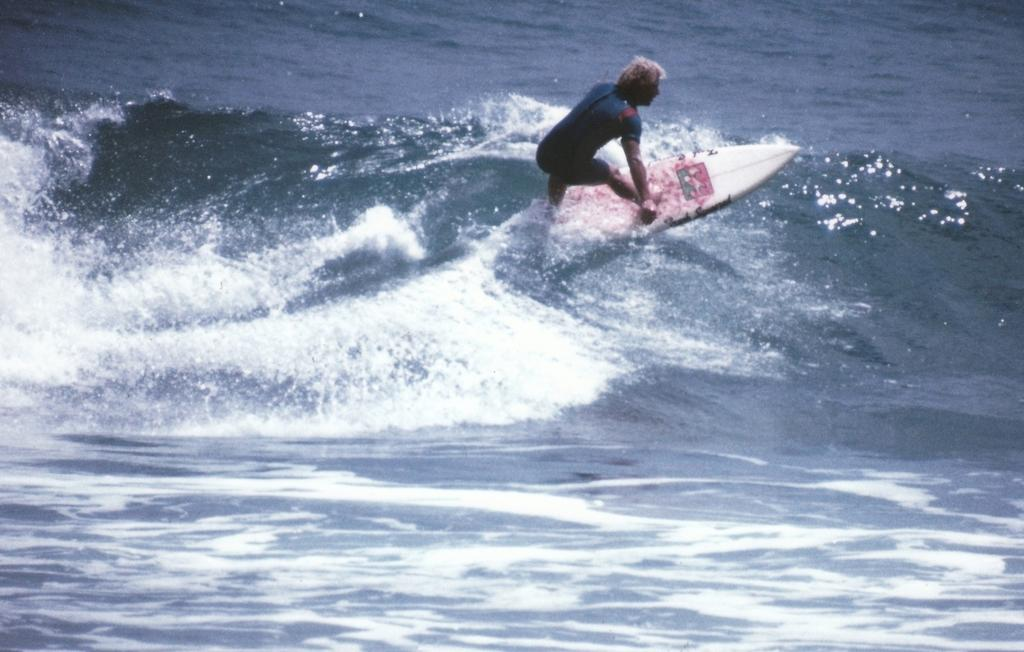What is the main subject of the image? There is a person in the image. What is the person doing in the image? The person is surfing on the water. How many men are riding horses in the image? There are no men or horses present in the image. Are there any deer visible in the image? There are no deer visible in the image. 